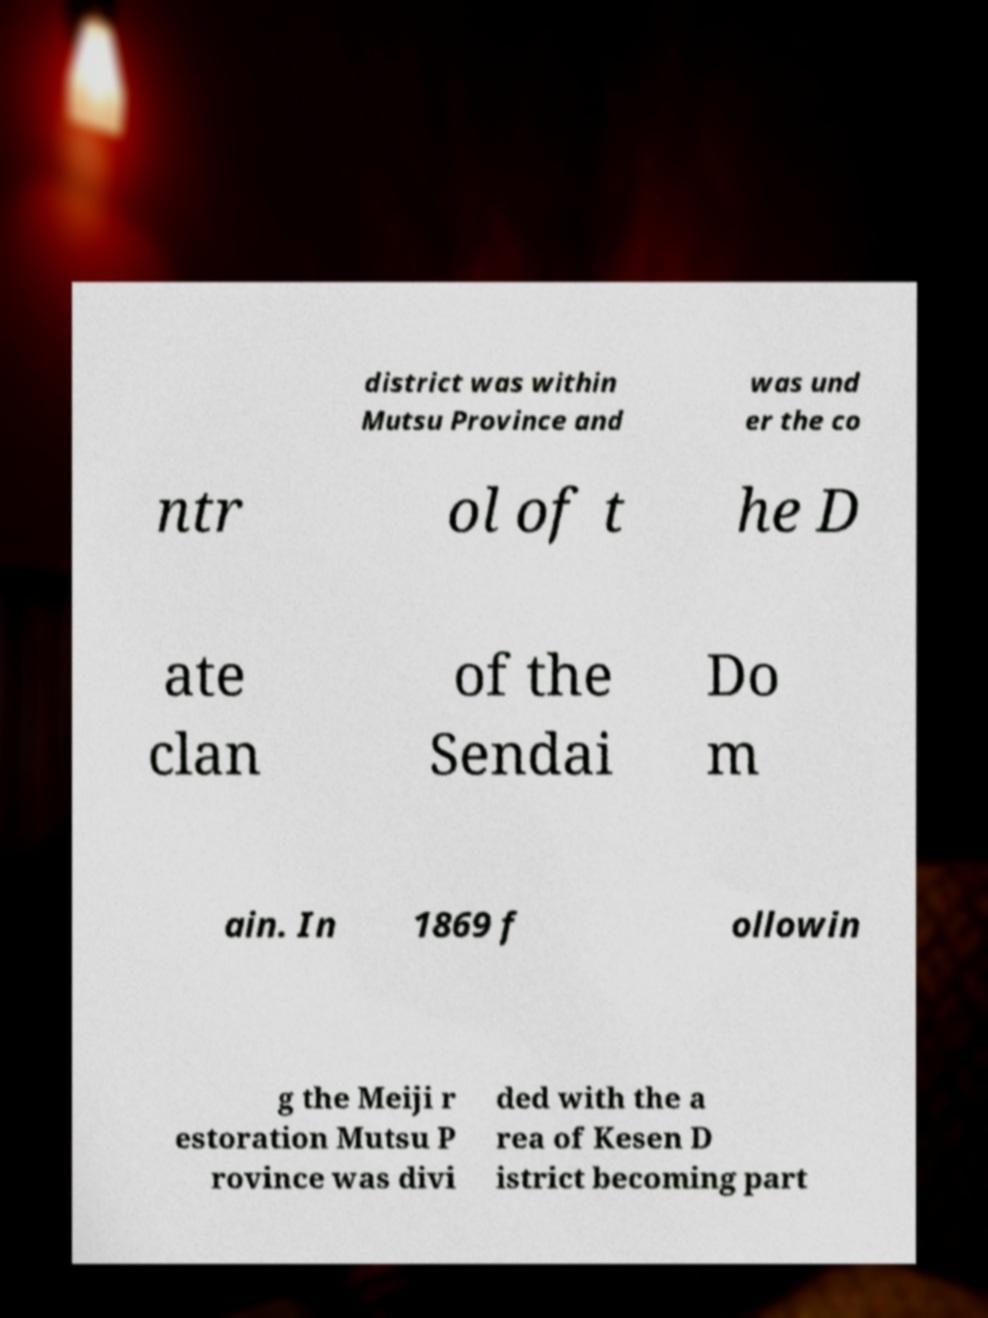For documentation purposes, I need the text within this image transcribed. Could you provide that? district was within Mutsu Province and was und er the co ntr ol of t he D ate clan of the Sendai Do m ain. In 1869 f ollowin g the Meiji r estoration Mutsu P rovince was divi ded with the a rea of Kesen D istrict becoming part 